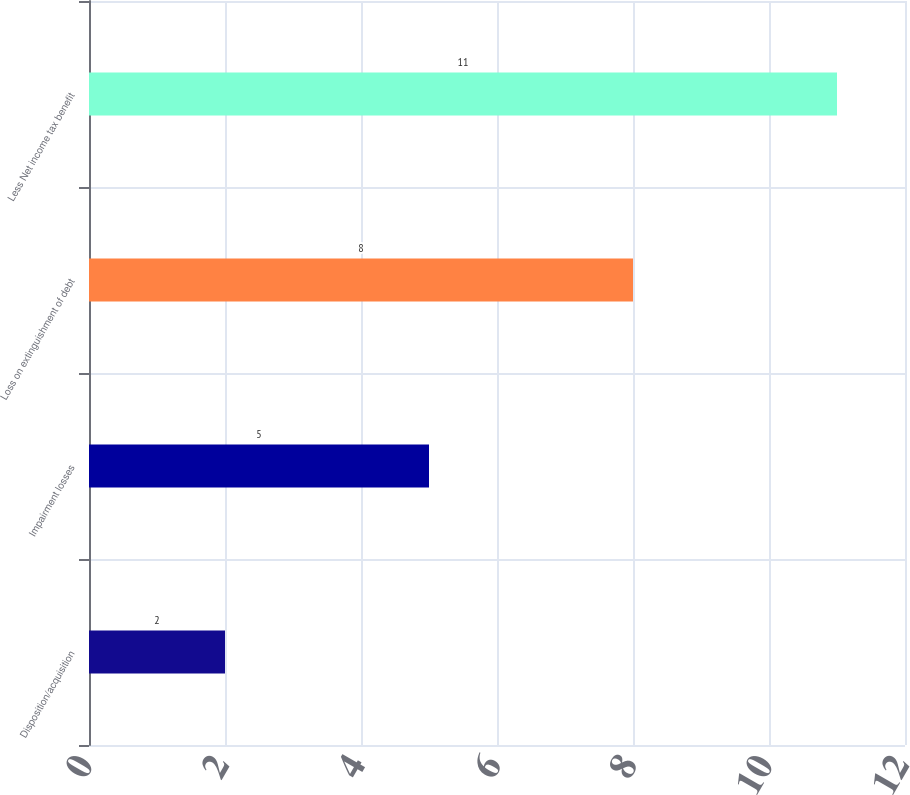Convert chart to OTSL. <chart><loc_0><loc_0><loc_500><loc_500><bar_chart><fcel>Disposition/acquisition<fcel>Impairment losses<fcel>Loss on extinguishment of debt<fcel>Less Net income tax benefit<nl><fcel>2<fcel>5<fcel>8<fcel>11<nl></chart> 